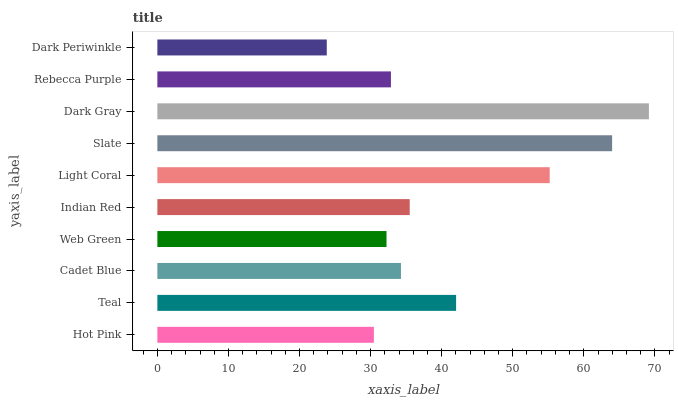Is Dark Periwinkle the minimum?
Answer yes or no. Yes. Is Dark Gray the maximum?
Answer yes or no. Yes. Is Teal the minimum?
Answer yes or no. No. Is Teal the maximum?
Answer yes or no. No. Is Teal greater than Hot Pink?
Answer yes or no. Yes. Is Hot Pink less than Teal?
Answer yes or no. Yes. Is Hot Pink greater than Teal?
Answer yes or no. No. Is Teal less than Hot Pink?
Answer yes or no. No. Is Indian Red the high median?
Answer yes or no. Yes. Is Cadet Blue the low median?
Answer yes or no. Yes. Is Rebecca Purple the high median?
Answer yes or no. No. Is Hot Pink the low median?
Answer yes or no. No. 